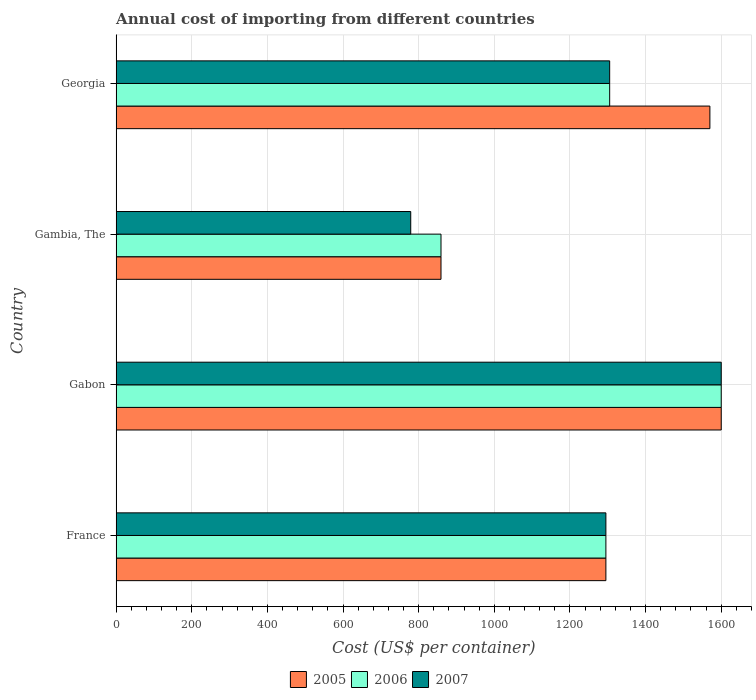How many different coloured bars are there?
Offer a terse response. 3. How many groups of bars are there?
Provide a succinct answer. 4. Are the number of bars per tick equal to the number of legend labels?
Your response must be concise. Yes. Are the number of bars on each tick of the Y-axis equal?
Give a very brief answer. Yes. How many bars are there on the 4th tick from the bottom?
Keep it short and to the point. 3. What is the label of the 1st group of bars from the top?
Ensure brevity in your answer.  Georgia. In how many cases, is the number of bars for a given country not equal to the number of legend labels?
Your answer should be very brief. 0. What is the total annual cost of importing in 2006 in Gabon?
Your response must be concise. 1600. Across all countries, what is the maximum total annual cost of importing in 2006?
Give a very brief answer. 1600. Across all countries, what is the minimum total annual cost of importing in 2007?
Offer a very short reply. 779. In which country was the total annual cost of importing in 2007 maximum?
Your answer should be compact. Gabon. In which country was the total annual cost of importing in 2007 minimum?
Provide a succinct answer. Gambia, The. What is the total total annual cost of importing in 2005 in the graph?
Make the answer very short. 5324. What is the difference between the total annual cost of importing in 2005 in France and that in Georgia?
Offer a terse response. -275. What is the difference between the total annual cost of importing in 2007 in Gabon and the total annual cost of importing in 2005 in Georgia?
Your answer should be compact. 30. What is the average total annual cost of importing in 2006 per country?
Offer a terse response. 1264.75. In how many countries, is the total annual cost of importing in 2006 greater than 200 US$?
Your answer should be compact. 4. What is the ratio of the total annual cost of importing in 2005 in Gabon to that in Gambia, The?
Ensure brevity in your answer.  1.86. Is the difference between the total annual cost of importing in 2007 in France and Georgia greater than the difference between the total annual cost of importing in 2006 in France and Georgia?
Make the answer very short. No. What is the difference between the highest and the lowest total annual cost of importing in 2005?
Keep it short and to the point. 741. What does the 3rd bar from the top in Gambia, The represents?
Provide a short and direct response. 2005. What does the 2nd bar from the bottom in Georgia represents?
Ensure brevity in your answer.  2006. How many bars are there?
Your answer should be very brief. 12. Are all the bars in the graph horizontal?
Offer a very short reply. Yes. Does the graph contain any zero values?
Your answer should be very brief. No. How many legend labels are there?
Offer a very short reply. 3. How are the legend labels stacked?
Make the answer very short. Horizontal. What is the title of the graph?
Your response must be concise. Annual cost of importing from different countries. What is the label or title of the X-axis?
Provide a succinct answer. Cost (US$ per container). What is the Cost (US$ per container) in 2005 in France?
Your answer should be very brief. 1295. What is the Cost (US$ per container) in 2006 in France?
Ensure brevity in your answer.  1295. What is the Cost (US$ per container) of 2007 in France?
Offer a terse response. 1295. What is the Cost (US$ per container) of 2005 in Gabon?
Keep it short and to the point. 1600. What is the Cost (US$ per container) of 2006 in Gabon?
Offer a terse response. 1600. What is the Cost (US$ per container) in 2007 in Gabon?
Make the answer very short. 1600. What is the Cost (US$ per container) in 2005 in Gambia, The?
Make the answer very short. 859. What is the Cost (US$ per container) of 2006 in Gambia, The?
Your answer should be compact. 859. What is the Cost (US$ per container) of 2007 in Gambia, The?
Keep it short and to the point. 779. What is the Cost (US$ per container) in 2005 in Georgia?
Give a very brief answer. 1570. What is the Cost (US$ per container) of 2006 in Georgia?
Provide a short and direct response. 1305. What is the Cost (US$ per container) of 2007 in Georgia?
Ensure brevity in your answer.  1305. Across all countries, what is the maximum Cost (US$ per container) in 2005?
Give a very brief answer. 1600. Across all countries, what is the maximum Cost (US$ per container) in 2006?
Your response must be concise. 1600. Across all countries, what is the maximum Cost (US$ per container) in 2007?
Make the answer very short. 1600. Across all countries, what is the minimum Cost (US$ per container) of 2005?
Your answer should be compact. 859. Across all countries, what is the minimum Cost (US$ per container) of 2006?
Give a very brief answer. 859. Across all countries, what is the minimum Cost (US$ per container) of 2007?
Your response must be concise. 779. What is the total Cost (US$ per container) of 2005 in the graph?
Offer a very short reply. 5324. What is the total Cost (US$ per container) of 2006 in the graph?
Make the answer very short. 5059. What is the total Cost (US$ per container) in 2007 in the graph?
Offer a very short reply. 4979. What is the difference between the Cost (US$ per container) in 2005 in France and that in Gabon?
Your answer should be very brief. -305. What is the difference between the Cost (US$ per container) in 2006 in France and that in Gabon?
Make the answer very short. -305. What is the difference between the Cost (US$ per container) in 2007 in France and that in Gabon?
Give a very brief answer. -305. What is the difference between the Cost (US$ per container) in 2005 in France and that in Gambia, The?
Offer a very short reply. 436. What is the difference between the Cost (US$ per container) of 2006 in France and that in Gambia, The?
Provide a short and direct response. 436. What is the difference between the Cost (US$ per container) of 2007 in France and that in Gambia, The?
Provide a succinct answer. 516. What is the difference between the Cost (US$ per container) in 2005 in France and that in Georgia?
Offer a terse response. -275. What is the difference between the Cost (US$ per container) in 2007 in France and that in Georgia?
Offer a terse response. -10. What is the difference between the Cost (US$ per container) in 2005 in Gabon and that in Gambia, The?
Make the answer very short. 741. What is the difference between the Cost (US$ per container) of 2006 in Gabon and that in Gambia, The?
Ensure brevity in your answer.  741. What is the difference between the Cost (US$ per container) in 2007 in Gabon and that in Gambia, The?
Your answer should be very brief. 821. What is the difference between the Cost (US$ per container) in 2005 in Gabon and that in Georgia?
Offer a terse response. 30. What is the difference between the Cost (US$ per container) of 2006 in Gabon and that in Georgia?
Your response must be concise. 295. What is the difference between the Cost (US$ per container) in 2007 in Gabon and that in Georgia?
Make the answer very short. 295. What is the difference between the Cost (US$ per container) of 2005 in Gambia, The and that in Georgia?
Offer a very short reply. -711. What is the difference between the Cost (US$ per container) of 2006 in Gambia, The and that in Georgia?
Make the answer very short. -446. What is the difference between the Cost (US$ per container) of 2007 in Gambia, The and that in Georgia?
Provide a succinct answer. -526. What is the difference between the Cost (US$ per container) of 2005 in France and the Cost (US$ per container) of 2006 in Gabon?
Your answer should be very brief. -305. What is the difference between the Cost (US$ per container) of 2005 in France and the Cost (US$ per container) of 2007 in Gabon?
Your answer should be very brief. -305. What is the difference between the Cost (US$ per container) of 2006 in France and the Cost (US$ per container) of 2007 in Gabon?
Offer a very short reply. -305. What is the difference between the Cost (US$ per container) in 2005 in France and the Cost (US$ per container) in 2006 in Gambia, The?
Make the answer very short. 436. What is the difference between the Cost (US$ per container) in 2005 in France and the Cost (US$ per container) in 2007 in Gambia, The?
Offer a terse response. 516. What is the difference between the Cost (US$ per container) of 2006 in France and the Cost (US$ per container) of 2007 in Gambia, The?
Your response must be concise. 516. What is the difference between the Cost (US$ per container) of 2005 in France and the Cost (US$ per container) of 2006 in Georgia?
Your response must be concise. -10. What is the difference between the Cost (US$ per container) of 2006 in France and the Cost (US$ per container) of 2007 in Georgia?
Your response must be concise. -10. What is the difference between the Cost (US$ per container) in 2005 in Gabon and the Cost (US$ per container) in 2006 in Gambia, The?
Offer a very short reply. 741. What is the difference between the Cost (US$ per container) in 2005 in Gabon and the Cost (US$ per container) in 2007 in Gambia, The?
Give a very brief answer. 821. What is the difference between the Cost (US$ per container) in 2006 in Gabon and the Cost (US$ per container) in 2007 in Gambia, The?
Your response must be concise. 821. What is the difference between the Cost (US$ per container) of 2005 in Gabon and the Cost (US$ per container) of 2006 in Georgia?
Keep it short and to the point. 295. What is the difference between the Cost (US$ per container) of 2005 in Gabon and the Cost (US$ per container) of 2007 in Georgia?
Provide a short and direct response. 295. What is the difference between the Cost (US$ per container) in 2006 in Gabon and the Cost (US$ per container) in 2007 in Georgia?
Offer a terse response. 295. What is the difference between the Cost (US$ per container) of 2005 in Gambia, The and the Cost (US$ per container) of 2006 in Georgia?
Provide a succinct answer. -446. What is the difference between the Cost (US$ per container) of 2005 in Gambia, The and the Cost (US$ per container) of 2007 in Georgia?
Your answer should be compact. -446. What is the difference between the Cost (US$ per container) in 2006 in Gambia, The and the Cost (US$ per container) in 2007 in Georgia?
Your answer should be compact. -446. What is the average Cost (US$ per container) of 2005 per country?
Offer a very short reply. 1331. What is the average Cost (US$ per container) of 2006 per country?
Provide a succinct answer. 1264.75. What is the average Cost (US$ per container) of 2007 per country?
Provide a short and direct response. 1244.75. What is the difference between the Cost (US$ per container) of 2005 and Cost (US$ per container) of 2006 in France?
Your answer should be very brief. 0. What is the difference between the Cost (US$ per container) in 2005 and Cost (US$ per container) in 2007 in France?
Your answer should be compact. 0. What is the difference between the Cost (US$ per container) in 2006 and Cost (US$ per container) in 2007 in France?
Your answer should be compact. 0. What is the difference between the Cost (US$ per container) of 2005 and Cost (US$ per container) of 2007 in Gabon?
Ensure brevity in your answer.  0. What is the difference between the Cost (US$ per container) of 2006 and Cost (US$ per container) of 2007 in Gabon?
Your response must be concise. 0. What is the difference between the Cost (US$ per container) of 2005 and Cost (US$ per container) of 2006 in Gambia, The?
Your answer should be very brief. 0. What is the difference between the Cost (US$ per container) in 2005 and Cost (US$ per container) in 2007 in Gambia, The?
Your response must be concise. 80. What is the difference between the Cost (US$ per container) in 2006 and Cost (US$ per container) in 2007 in Gambia, The?
Offer a very short reply. 80. What is the difference between the Cost (US$ per container) in 2005 and Cost (US$ per container) in 2006 in Georgia?
Provide a short and direct response. 265. What is the difference between the Cost (US$ per container) in 2005 and Cost (US$ per container) in 2007 in Georgia?
Keep it short and to the point. 265. What is the ratio of the Cost (US$ per container) of 2005 in France to that in Gabon?
Keep it short and to the point. 0.81. What is the ratio of the Cost (US$ per container) of 2006 in France to that in Gabon?
Ensure brevity in your answer.  0.81. What is the ratio of the Cost (US$ per container) in 2007 in France to that in Gabon?
Ensure brevity in your answer.  0.81. What is the ratio of the Cost (US$ per container) in 2005 in France to that in Gambia, The?
Offer a terse response. 1.51. What is the ratio of the Cost (US$ per container) in 2006 in France to that in Gambia, The?
Keep it short and to the point. 1.51. What is the ratio of the Cost (US$ per container) of 2007 in France to that in Gambia, The?
Offer a very short reply. 1.66. What is the ratio of the Cost (US$ per container) of 2005 in France to that in Georgia?
Offer a terse response. 0.82. What is the ratio of the Cost (US$ per container) in 2006 in France to that in Georgia?
Your response must be concise. 0.99. What is the ratio of the Cost (US$ per container) in 2005 in Gabon to that in Gambia, The?
Your response must be concise. 1.86. What is the ratio of the Cost (US$ per container) of 2006 in Gabon to that in Gambia, The?
Offer a terse response. 1.86. What is the ratio of the Cost (US$ per container) in 2007 in Gabon to that in Gambia, The?
Your answer should be very brief. 2.05. What is the ratio of the Cost (US$ per container) of 2005 in Gabon to that in Georgia?
Keep it short and to the point. 1.02. What is the ratio of the Cost (US$ per container) of 2006 in Gabon to that in Georgia?
Give a very brief answer. 1.23. What is the ratio of the Cost (US$ per container) in 2007 in Gabon to that in Georgia?
Keep it short and to the point. 1.23. What is the ratio of the Cost (US$ per container) of 2005 in Gambia, The to that in Georgia?
Make the answer very short. 0.55. What is the ratio of the Cost (US$ per container) of 2006 in Gambia, The to that in Georgia?
Ensure brevity in your answer.  0.66. What is the ratio of the Cost (US$ per container) in 2007 in Gambia, The to that in Georgia?
Keep it short and to the point. 0.6. What is the difference between the highest and the second highest Cost (US$ per container) in 2005?
Give a very brief answer. 30. What is the difference between the highest and the second highest Cost (US$ per container) in 2006?
Keep it short and to the point. 295. What is the difference between the highest and the second highest Cost (US$ per container) in 2007?
Your answer should be very brief. 295. What is the difference between the highest and the lowest Cost (US$ per container) in 2005?
Keep it short and to the point. 741. What is the difference between the highest and the lowest Cost (US$ per container) of 2006?
Give a very brief answer. 741. What is the difference between the highest and the lowest Cost (US$ per container) of 2007?
Make the answer very short. 821. 